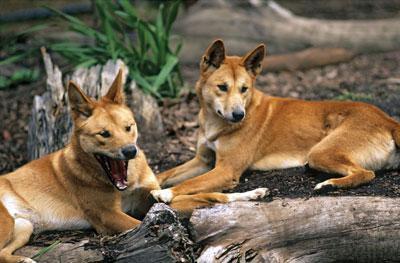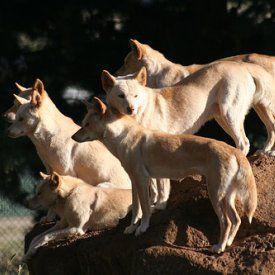The first image is the image on the left, the second image is the image on the right. Assess this claim about the two images: "Several animals are standing in the grass in the image on the left.". Correct or not? Answer yes or no. No. The first image is the image on the left, the second image is the image on the right. For the images shown, is this caption "The right image includes more than twice the number of dogs as the left image." true? Answer yes or no. Yes. 